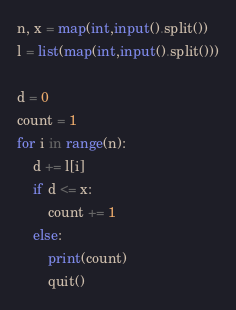<code> <loc_0><loc_0><loc_500><loc_500><_Python_>n, x = map(int,input().split())
l = list(map(int,input().split()))

d = 0
count = 1
for i in range(n):
    d += l[i]
    if d <= x:
        count += 1
    else:
        print(count)
        quit()</code> 